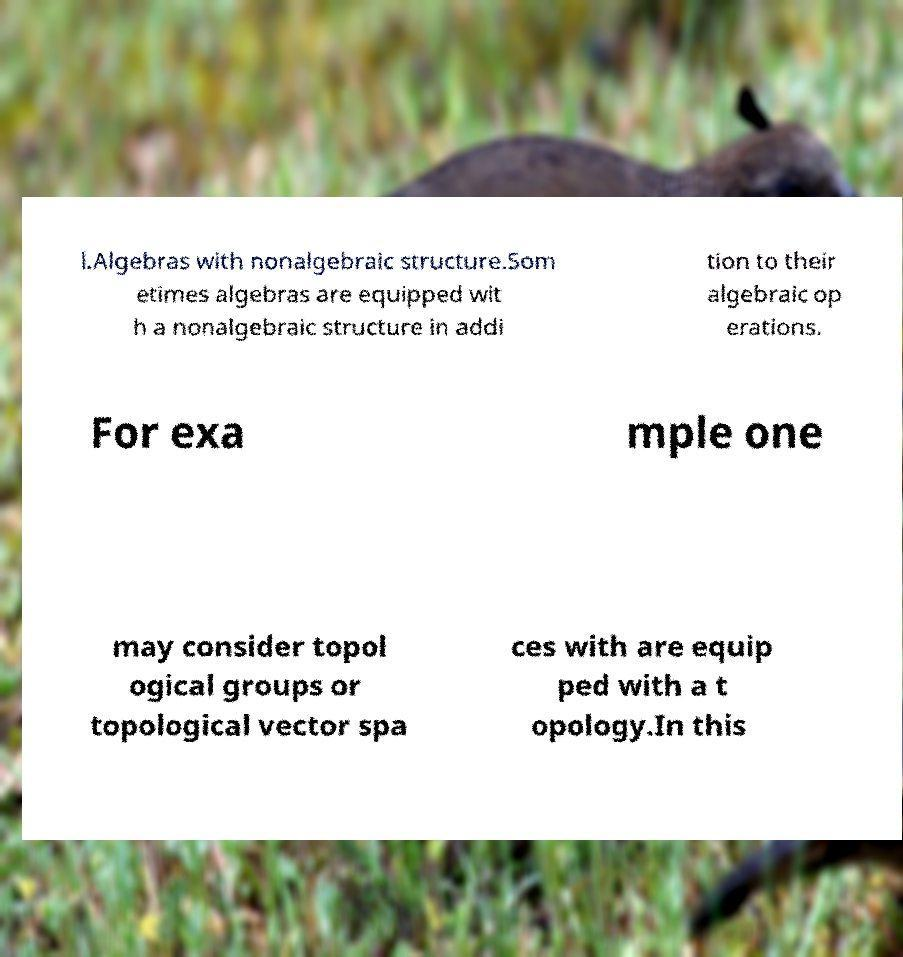Can you read and provide the text displayed in the image?This photo seems to have some interesting text. Can you extract and type it out for me? l.Algebras with nonalgebraic structure.Som etimes algebras are equipped wit h a nonalgebraic structure in addi tion to their algebraic op erations. For exa mple one may consider topol ogical groups or topological vector spa ces with are equip ped with a t opology.In this 